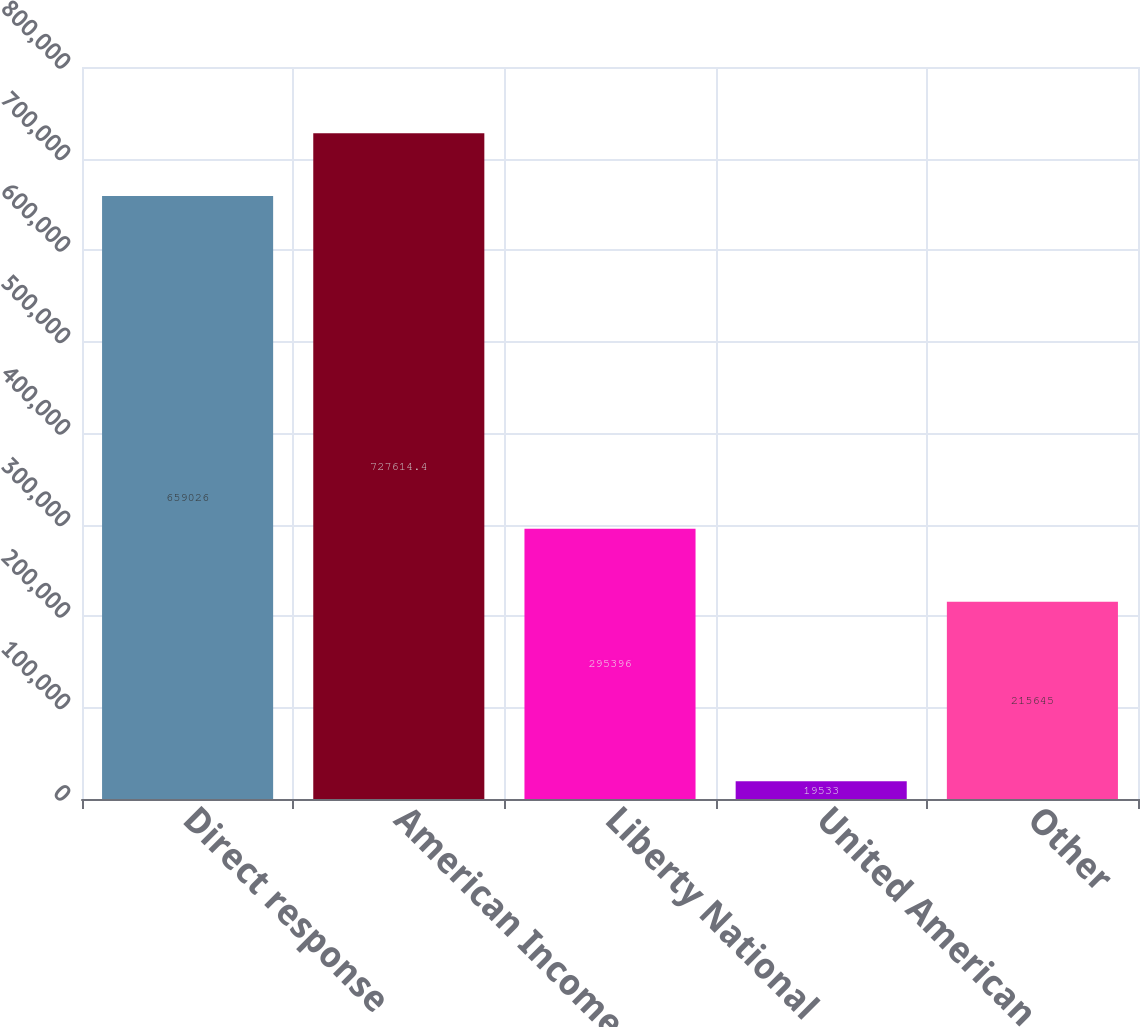Convert chart. <chart><loc_0><loc_0><loc_500><loc_500><bar_chart><fcel>Direct response<fcel>American Income<fcel>Liberty National<fcel>United American<fcel>Other<nl><fcel>659026<fcel>727614<fcel>295396<fcel>19533<fcel>215645<nl></chart> 